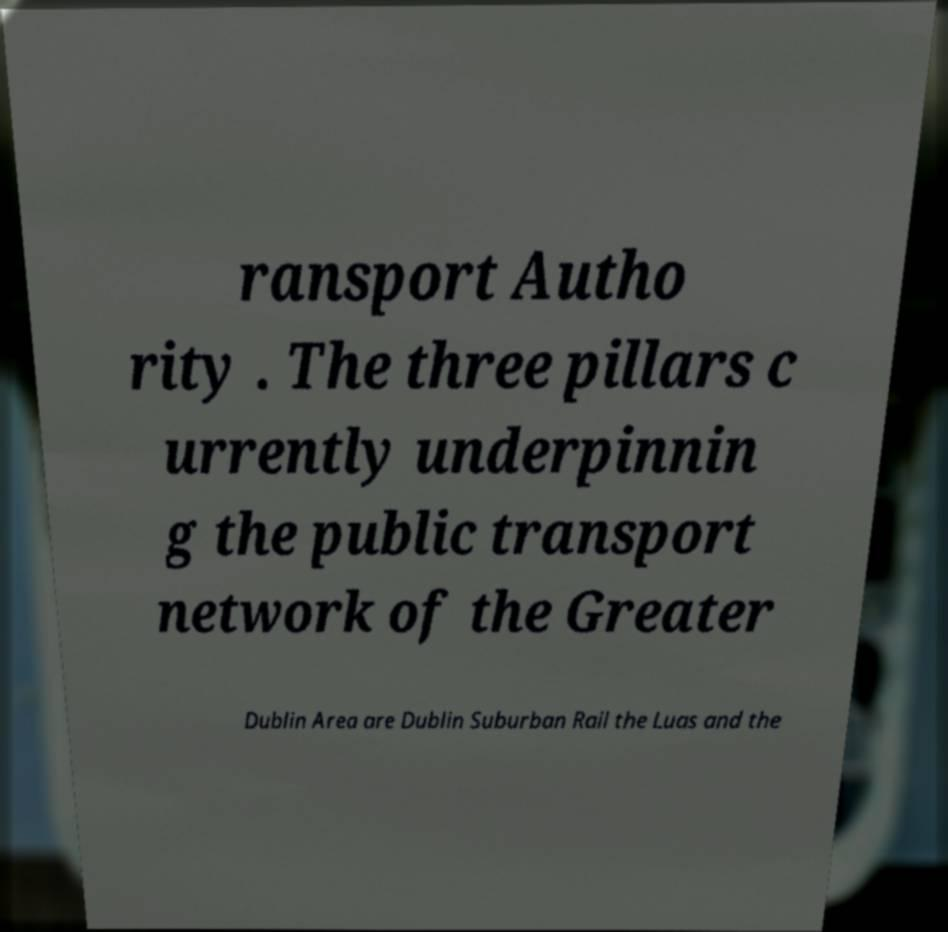For documentation purposes, I need the text within this image transcribed. Could you provide that? ransport Autho rity . The three pillars c urrently underpinnin g the public transport network of the Greater Dublin Area are Dublin Suburban Rail the Luas and the 